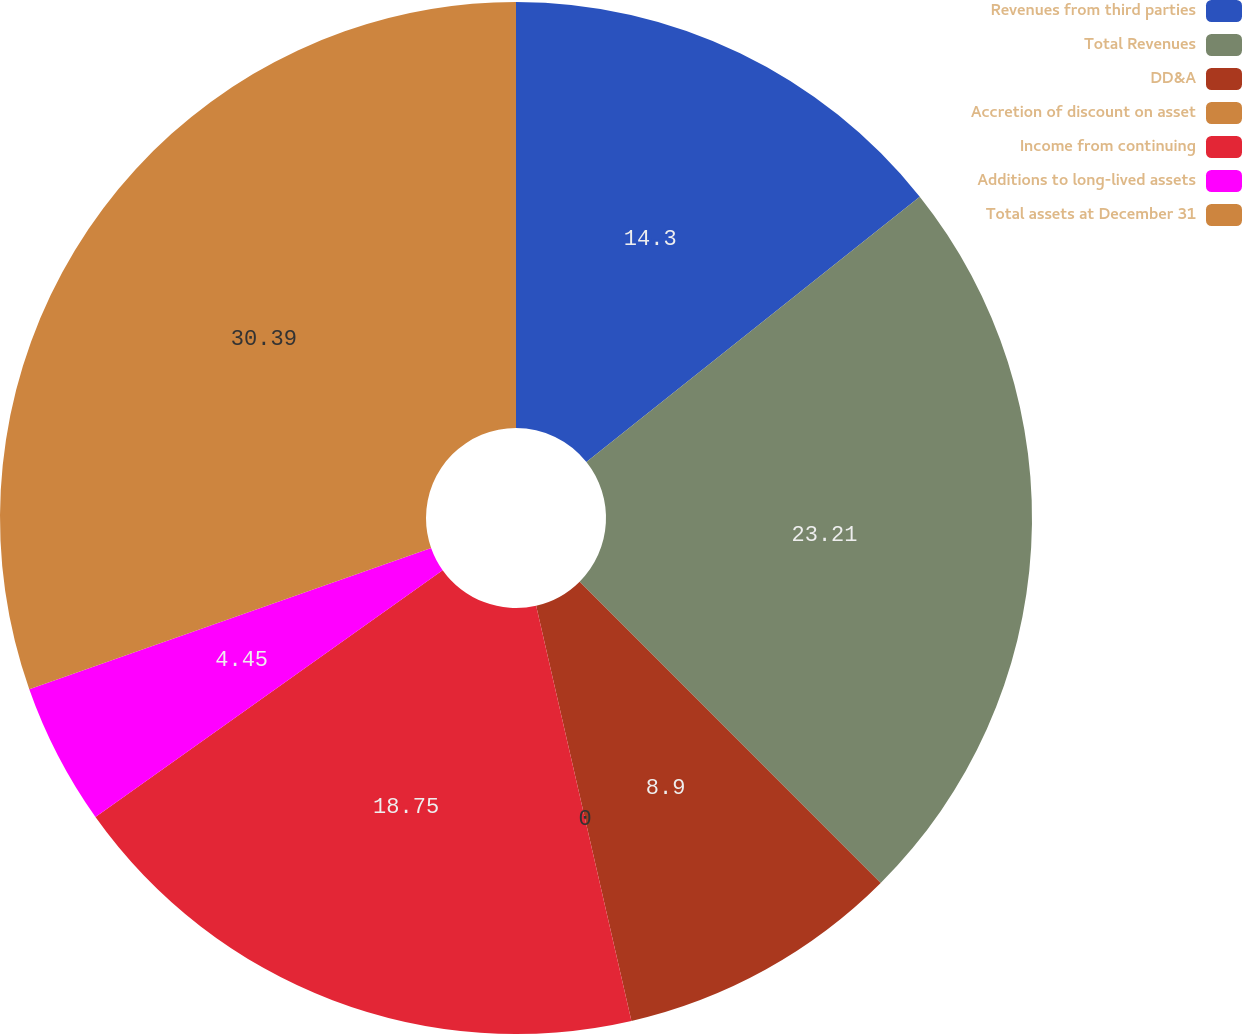Convert chart to OTSL. <chart><loc_0><loc_0><loc_500><loc_500><pie_chart><fcel>Revenues from third parties<fcel>Total Revenues<fcel>DD&A<fcel>Accretion of discount on asset<fcel>Income from continuing<fcel>Additions to long-lived assets<fcel>Total assets at December 31<nl><fcel>14.3%<fcel>23.2%<fcel>8.9%<fcel>0.0%<fcel>18.75%<fcel>4.45%<fcel>30.38%<nl></chart> 